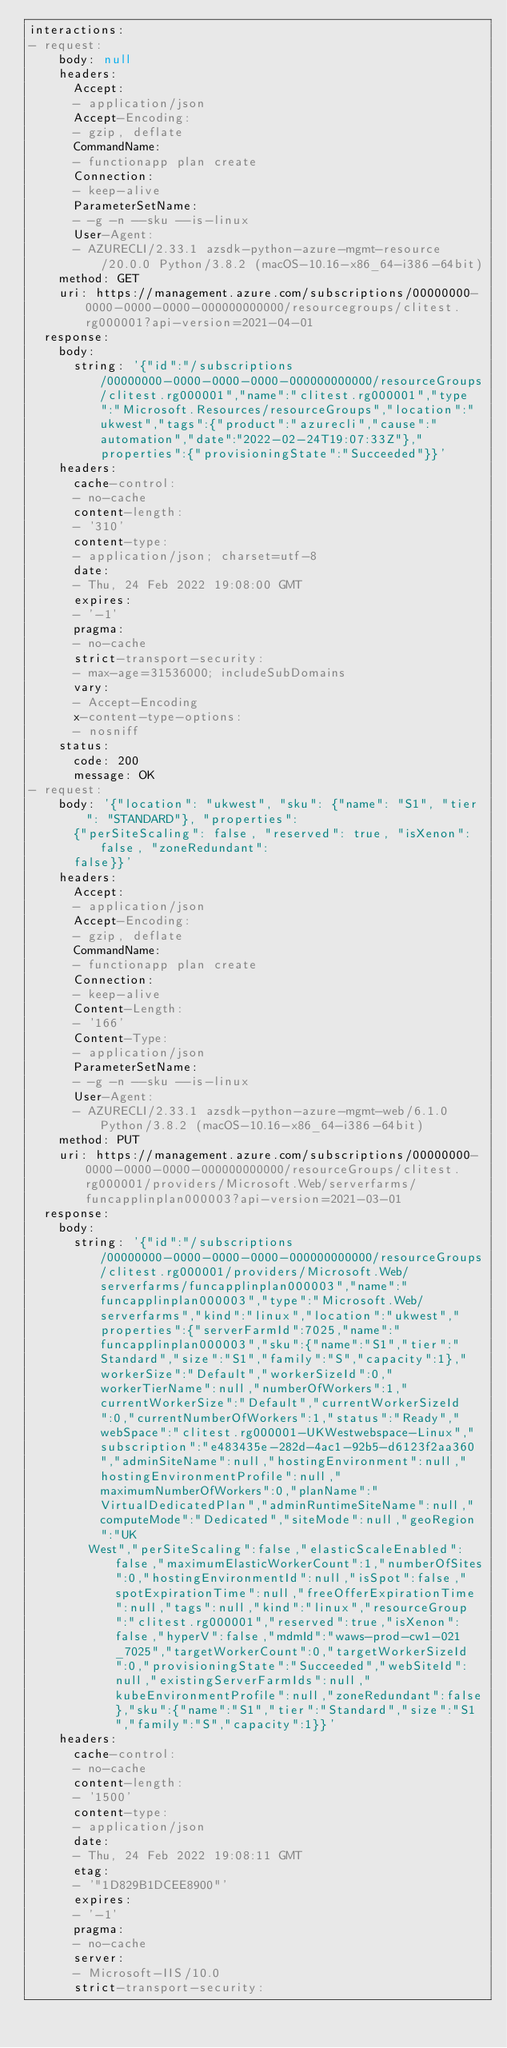<code> <loc_0><loc_0><loc_500><loc_500><_YAML_>interactions:
- request:
    body: null
    headers:
      Accept:
      - application/json
      Accept-Encoding:
      - gzip, deflate
      CommandName:
      - functionapp plan create
      Connection:
      - keep-alive
      ParameterSetName:
      - -g -n --sku --is-linux
      User-Agent:
      - AZURECLI/2.33.1 azsdk-python-azure-mgmt-resource/20.0.0 Python/3.8.2 (macOS-10.16-x86_64-i386-64bit)
    method: GET
    uri: https://management.azure.com/subscriptions/00000000-0000-0000-0000-000000000000/resourcegroups/clitest.rg000001?api-version=2021-04-01
  response:
    body:
      string: '{"id":"/subscriptions/00000000-0000-0000-0000-000000000000/resourceGroups/clitest.rg000001","name":"clitest.rg000001","type":"Microsoft.Resources/resourceGroups","location":"ukwest","tags":{"product":"azurecli","cause":"automation","date":"2022-02-24T19:07:33Z"},"properties":{"provisioningState":"Succeeded"}}'
    headers:
      cache-control:
      - no-cache
      content-length:
      - '310'
      content-type:
      - application/json; charset=utf-8
      date:
      - Thu, 24 Feb 2022 19:08:00 GMT
      expires:
      - '-1'
      pragma:
      - no-cache
      strict-transport-security:
      - max-age=31536000; includeSubDomains
      vary:
      - Accept-Encoding
      x-content-type-options:
      - nosniff
    status:
      code: 200
      message: OK
- request:
    body: '{"location": "ukwest", "sku": {"name": "S1", "tier": "STANDARD"}, "properties":
      {"perSiteScaling": false, "reserved": true, "isXenon": false, "zoneRedundant":
      false}}'
    headers:
      Accept:
      - application/json
      Accept-Encoding:
      - gzip, deflate
      CommandName:
      - functionapp plan create
      Connection:
      - keep-alive
      Content-Length:
      - '166'
      Content-Type:
      - application/json
      ParameterSetName:
      - -g -n --sku --is-linux
      User-Agent:
      - AZURECLI/2.33.1 azsdk-python-azure-mgmt-web/6.1.0 Python/3.8.2 (macOS-10.16-x86_64-i386-64bit)
    method: PUT
    uri: https://management.azure.com/subscriptions/00000000-0000-0000-0000-000000000000/resourceGroups/clitest.rg000001/providers/Microsoft.Web/serverfarms/funcapplinplan000003?api-version=2021-03-01
  response:
    body:
      string: '{"id":"/subscriptions/00000000-0000-0000-0000-000000000000/resourceGroups/clitest.rg000001/providers/Microsoft.Web/serverfarms/funcapplinplan000003","name":"funcapplinplan000003","type":"Microsoft.Web/serverfarms","kind":"linux","location":"ukwest","properties":{"serverFarmId":7025,"name":"funcapplinplan000003","sku":{"name":"S1","tier":"Standard","size":"S1","family":"S","capacity":1},"workerSize":"Default","workerSizeId":0,"workerTierName":null,"numberOfWorkers":1,"currentWorkerSize":"Default","currentWorkerSizeId":0,"currentNumberOfWorkers":1,"status":"Ready","webSpace":"clitest.rg000001-UKWestwebspace-Linux","subscription":"e483435e-282d-4ac1-92b5-d6123f2aa360","adminSiteName":null,"hostingEnvironment":null,"hostingEnvironmentProfile":null,"maximumNumberOfWorkers":0,"planName":"VirtualDedicatedPlan","adminRuntimeSiteName":null,"computeMode":"Dedicated","siteMode":null,"geoRegion":"UK
        West","perSiteScaling":false,"elasticScaleEnabled":false,"maximumElasticWorkerCount":1,"numberOfSites":0,"hostingEnvironmentId":null,"isSpot":false,"spotExpirationTime":null,"freeOfferExpirationTime":null,"tags":null,"kind":"linux","resourceGroup":"clitest.rg000001","reserved":true,"isXenon":false,"hyperV":false,"mdmId":"waws-prod-cw1-021_7025","targetWorkerCount":0,"targetWorkerSizeId":0,"provisioningState":"Succeeded","webSiteId":null,"existingServerFarmIds":null,"kubeEnvironmentProfile":null,"zoneRedundant":false},"sku":{"name":"S1","tier":"Standard","size":"S1","family":"S","capacity":1}}'
    headers:
      cache-control:
      - no-cache
      content-length:
      - '1500'
      content-type:
      - application/json
      date:
      - Thu, 24 Feb 2022 19:08:11 GMT
      etag:
      - '"1D829B1DCEE8900"'
      expires:
      - '-1'
      pragma:
      - no-cache
      server:
      - Microsoft-IIS/10.0
      strict-transport-security:</code> 